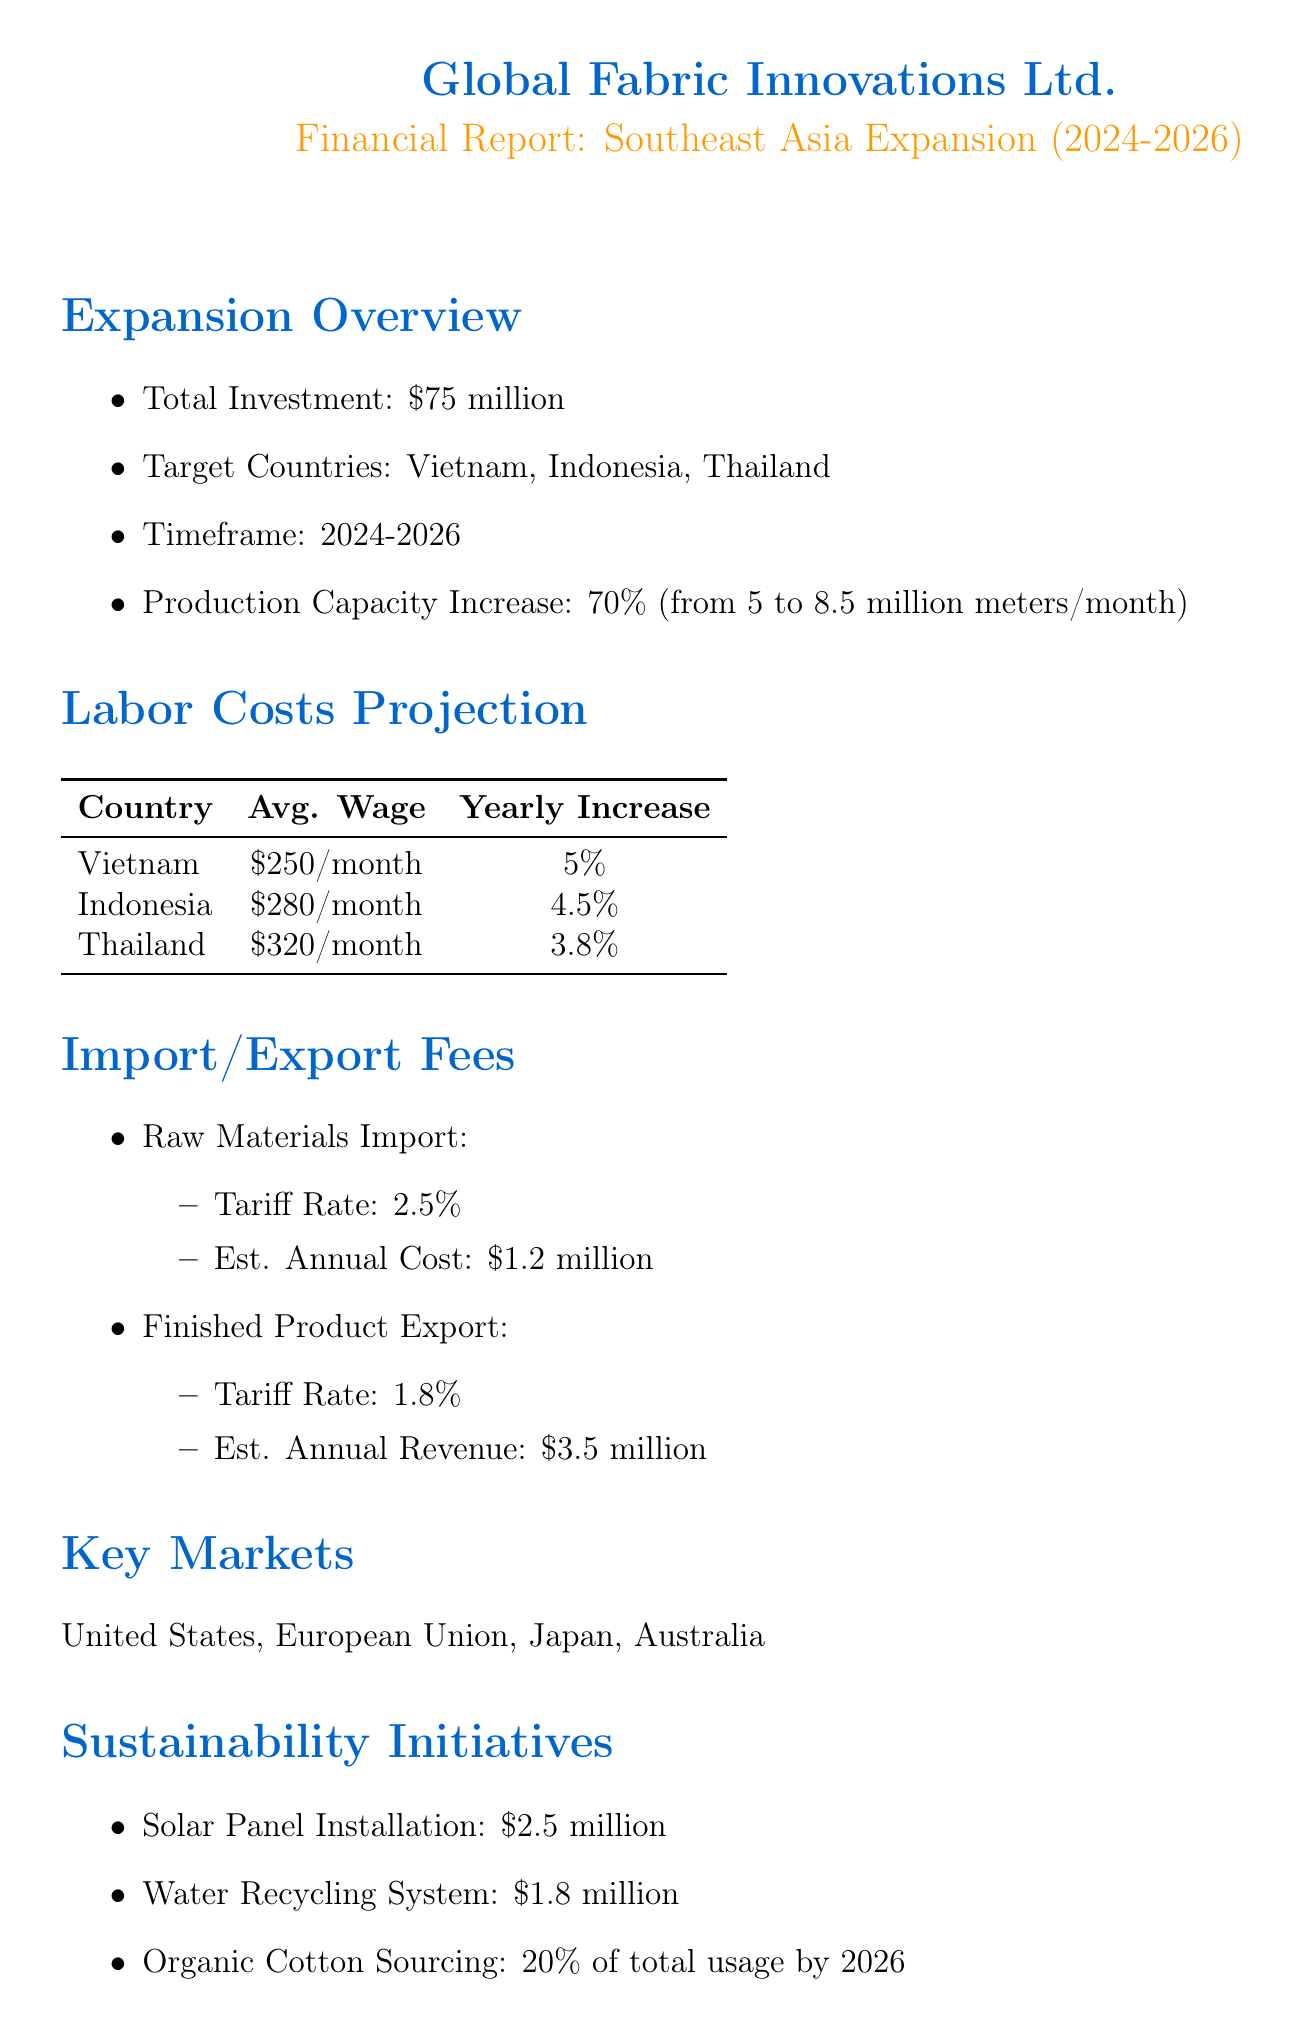What is the total investment for the expansion? The total investment is explicitly mentioned in the document.
Answer: $75 million What are the target countries for expansion? The target countries are listed in the expansion overview section.
Answer: Vietnam, Indonesia, Thailand What is the average wage in Thailand? The average wage is specified in the labor costs projection table.
Answer: $320 per month What is the estimated annual cost for raw materials import? This figure is indicated under the import/export fees section.
Answer: $1.2 million What is the projected production capacity after the expansion? The projected capacity is detailed in the expansion overview section.
Answer: 8.5 million meters per month What is the yearly increase percentage for labor costs in Vietnam? The yearly increase is shown in the labor costs projection table.
Answer: 5% Which sustainability initiative has the highest cost? The costs of sustainability initiatives are listed, requiring comparison to find the highest.
Answer: Solar Panel Installation What percentage increase in production capacity is expected? The percentage increase is provided in the expansion overview section.
Answer: 70% What are the key markets identified for this expansion? The key markets are clearly mentioned in the document.
Answer: United States, European Union, Japan, Australia 